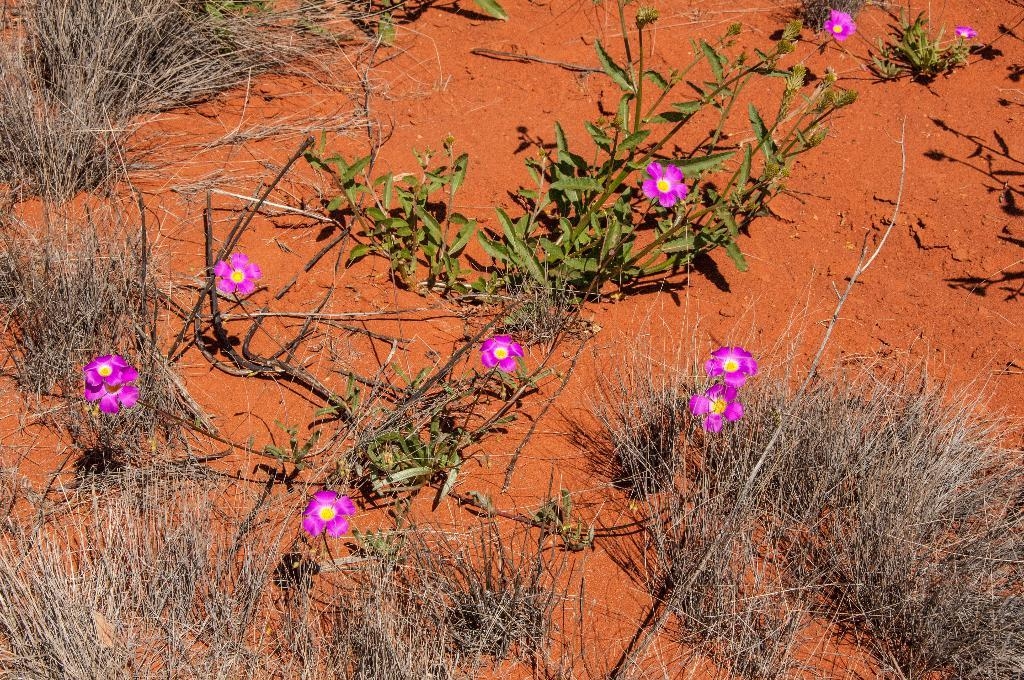What color is the soil in the image? The soil in the image is red. What is growing on the red soil? There are flower plants on the red soil. What else can be seen on the red soil besides the flower plants? Dry grass is present on the red soil. What type of orange is being peeled on the page in the image? There is no orange or page present in the image; it features red soil with flower plants and dry grass. 